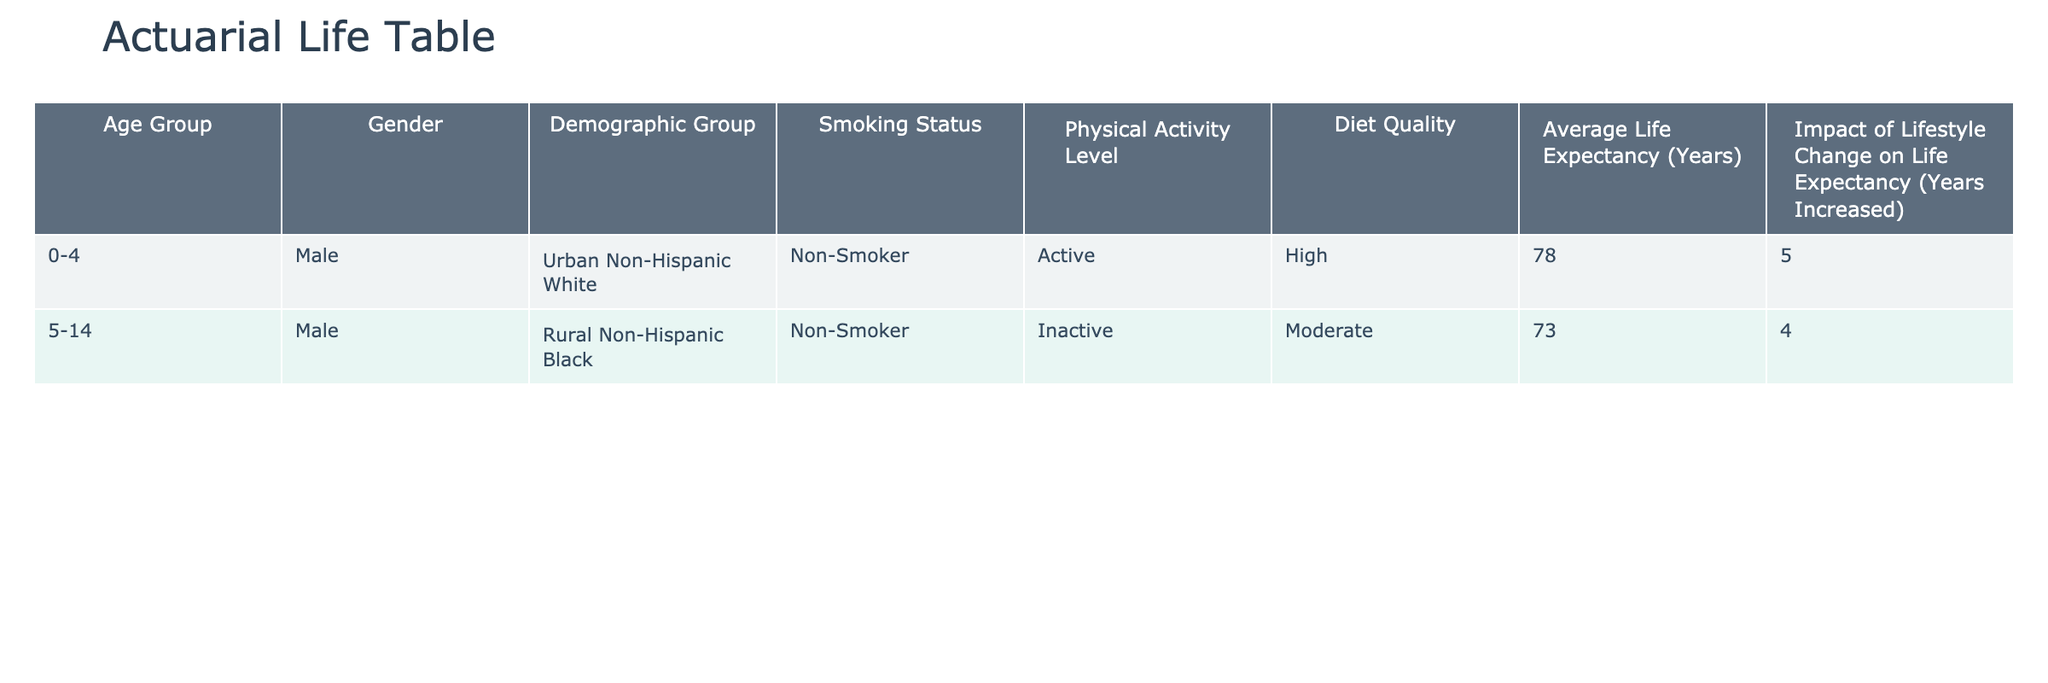What is the average life expectancy for the Urban Non-Hispanic White demographic group? The table indicates that the average life expectancy for the Urban Non-Hispanic White demographic group is 78 years.
Answer: 78 years How many years can a Rural Non-Hispanic Black individual increase their life expectancy by becoming a non-smoker? The table shows that the impact of lifestyle change for the Rural Non-Hispanic Black group is 4 years for non-smokers; therefore, they can increase their life expectancy by this amount.
Answer: 4 years Is the average life expectancy for males in the age group 0-4 higher than that of males in the age group 5-14? According to the table, the average life expectancy for males in the age group 0-4 is 78 years, while for those in the age group 5-14 it is 73 years. Since 78 is greater than 73, the statement is true.
Answer: Yes What is the difference in average life expectancy between active and inactive individuals in the table? In the table, active individuals (Urban Non-Hispanic White) have an average life expectancy of 78 years, while inactive individuals (Rural Non-Hispanic Black) have 73 years. Therefore, the difference is 78 - 73 = 5 years.
Answer: 5 years Can you identify any demographic group that could significantly extend their life expectancy with improved diet quality? The table does not provide explicit information about diet quality's impact on life expectancy for these specific demographics, so we cannot determine a significant group.
Answer: No How many years of life expectancy would a Rural Non-Hispanic Black male have if they improved their lifestyle to match that of the Urban Non-Hispanic White male? The Urban Non-Hispanic White male has an average life expectancy of 78 years and can increase it by 5 years with lifestyle changes. The Rural Non-Hispanic Black male has 73 years and can increase it by 4 years. Therefore, if the Rural Non-Hispanic Black male matched the Urban lifestyle, they would have 73 + 4 + 5 = 82 years.
Answer: 82 years Which group has the highest potential increase in life expectancy due to lifestyle changes? The Urban Non-Hispanic White male can potentially increase their life expectancy by 5 years, while the Rural Non-Hispanic Black male can increase it by 4 years. Thus, the Urban Non-Hispanic White group has the highest potential increase in life expectancy due to lifestyle changes.
Answer: Urban Non-Hispanic White If all males in the table adopted healthier lifestyles, what would be the new average life expectancy? The new life expectancy would be calculated as follows: Urban Non-Hispanic White increases from 78 to 83 (78 + 5) and Rural Non-Hispanic Black increases from 73 to 77 (73 + 4). Now averaging these: (83 + 77) / 2 = 80.
Answer: 80 years 